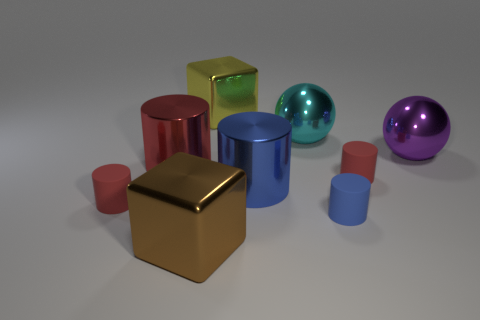The big purple thing that is the same material as the big brown block is what shape?
Ensure brevity in your answer.  Sphere. Are there fewer large purple metal spheres on the left side of the large brown metal object than shiny things?
Keep it short and to the point. Yes. Is the shape of the large purple metal object the same as the big brown object?
Give a very brief answer. No. How many shiny things are either big green cylinders or large red cylinders?
Provide a short and direct response. 1. Are there any yellow things of the same size as the purple shiny ball?
Your answer should be compact. Yes. What number of cylinders are the same size as the cyan shiny sphere?
Give a very brief answer. 2. Does the blue cylinder left of the cyan shiny object have the same size as the block that is behind the brown shiny block?
Give a very brief answer. Yes. What number of things are large metallic spheres or tiny red rubber cylinders that are to the left of the brown shiny block?
Offer a very short reply. 3. The tiny thing that is behind the tiny rubber object on the left side of the metallic ball left of the small blue cylinder is made of what material?
Offer a very short reply. Rubber. There is a yellow object that is made of the same material as the large cyan sphere; what size is it?
Offer a very short reply. Large. 